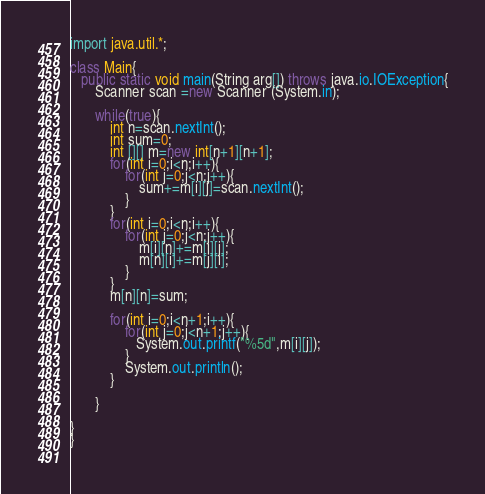<code> <loc_0><loc_0><loc_500><loc_500><_Java_>import java.util.*;

class Main{
   public static void main(String arg[]) throws java.io.IOException{
       Scanner scan =new Scanner (System.in);
    
       while(true){
    	   int n=scan.nextInt();
    	   int sum=0;
    	   int [][] m=new int[n+1][n+1];
    	   for(int i=0;i<n;i++){
    		   for(int j=0;j<n;j++){
    			   sum+=m[i][j]=scan.nextInt();
    		   }
    	   }
    	   for(int i=0;i<n;i++){
    		   for(int j=0;j<n;j++){
    			   m[i][n]+=m[i][j];
    			   m[n][i]+=m[j][i];
    		   }
    	   }
    	   m[n][n]=sum;
    	   
    	   for(int i=0;i<n+1;i++){
    		   for(int j=0;j<n+1;j++){
    			  System.out.printf("%5d",m[i][j]);
    		   }
    		   System.out.println();
    	   }
   
       }
    
}
}
    </code> 